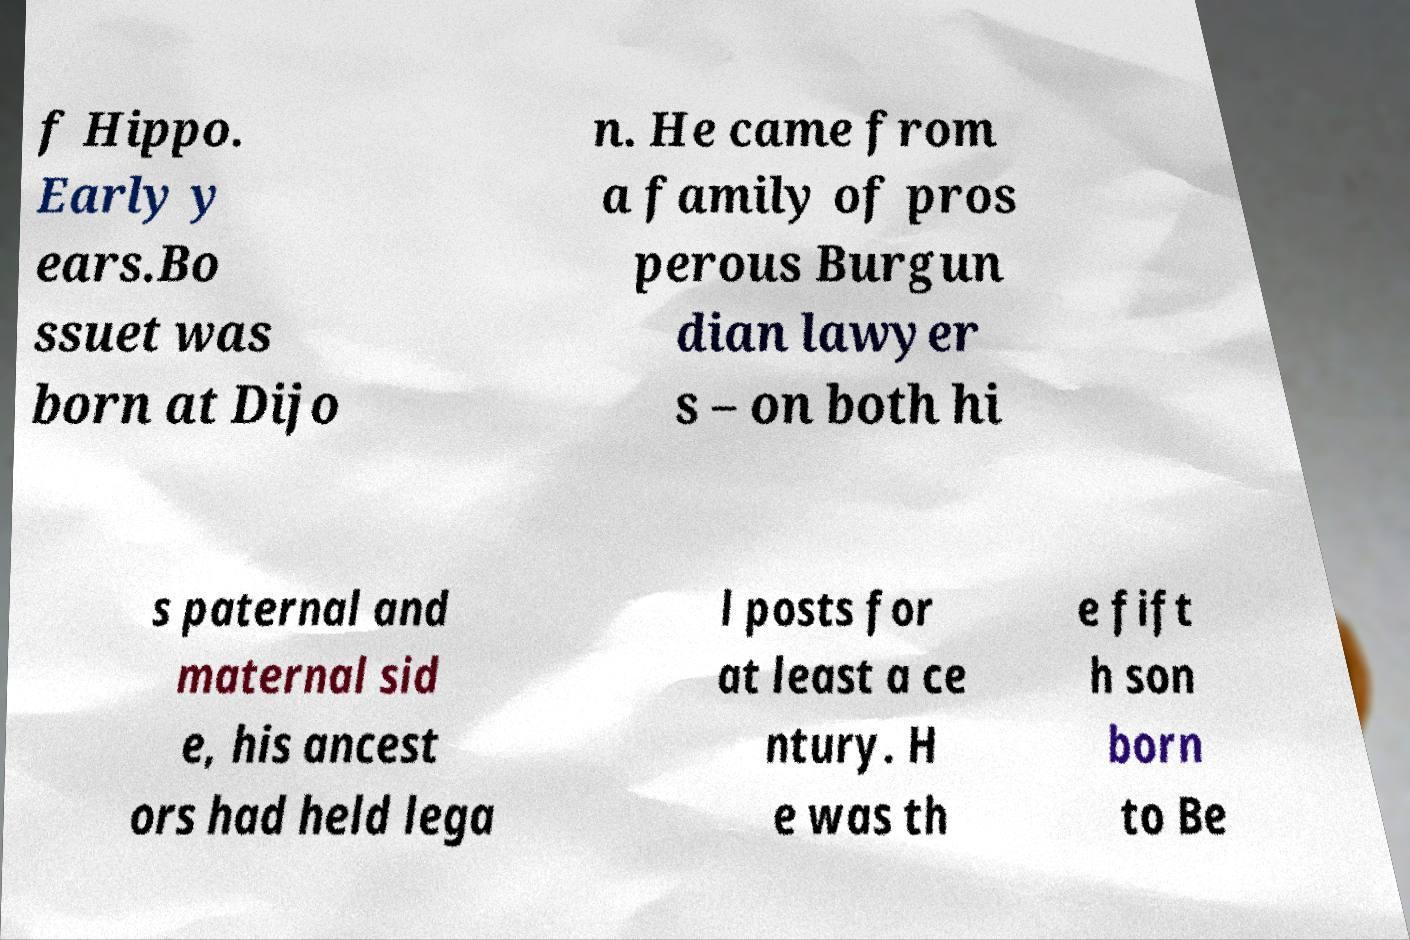Could you assist in decoding the text presented in this image and type it out clearly? f Hippo. Early y ears.Bo ssuet was born at Dijo n. He came from a family of pros perous Burgun dian lawyer s – on both hi s paternal and maternal sid e, his ancest ors had held lega l posts for at least a ce ntury. H e was th e fift h son born to Be 